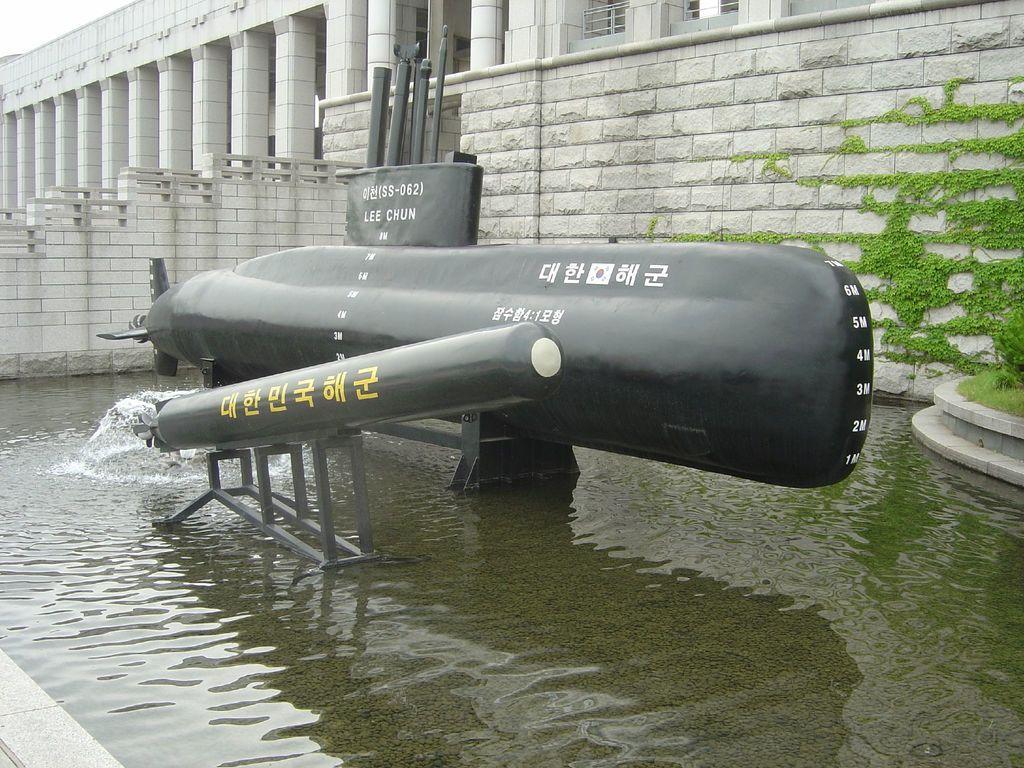Can you describe this image briefly? In the center of the image we can see a pipe line. At the bottom there is water. In the background there is a building. On the right there is a plant. 